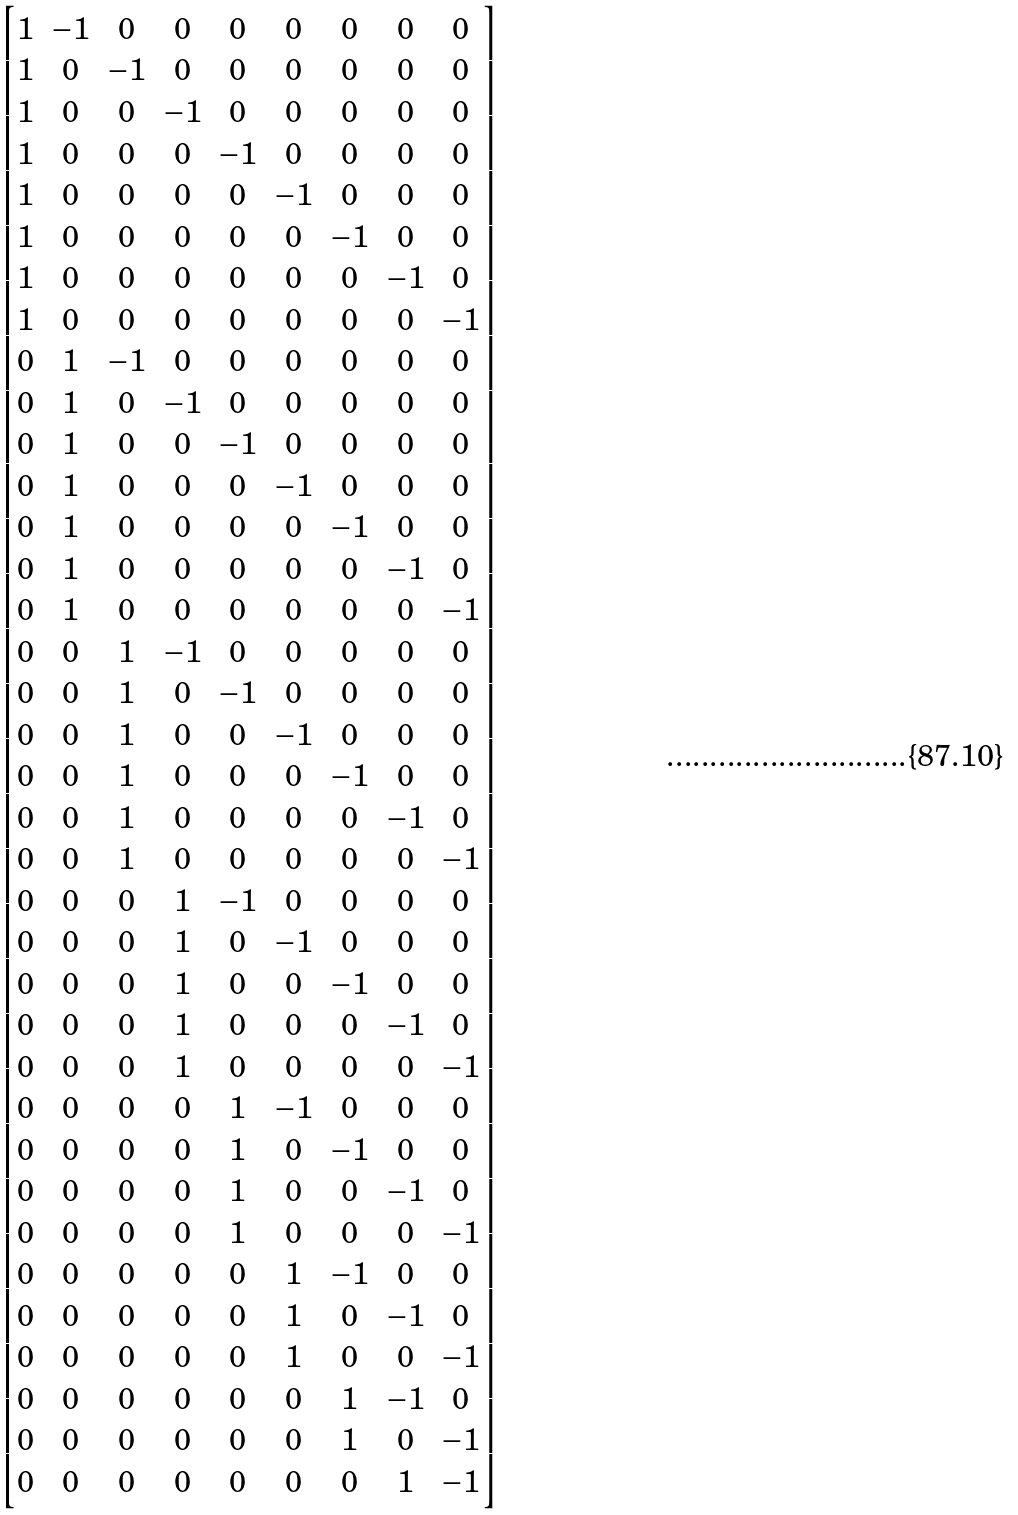Convert formula to latex. <formula><loc_0><loc_0><loc_500><loc_500>\begin{bmatrix} 1 & - 1 & 0 & 0 & 0 & 0 & 0 & 0 & 0 \\ 1 & 0 & - 1 & 0 & 0 & 0 & 0 & 0 & 0 \\ 1 & 0 & 0 & - 1 & 0 & 0 & 0 & 0 & 0 \\ 1 & 0 & 0 & 0 & - 1 & 0 & 0 & 0 & 0 \\ 1 & 0 & 0 & 0 & 0 & - 1 & 0 & 0 & 0 \\ 1 & 0 & 0 & 0 & 0 & 0 & - 1 & 0 & 0 \\ 1 & 0 & 0 & 0 & 0 & 0 & 0 & - 1 & 0 \\ 1 & 0 & 0 & 0 & 0 & 0 & 0 & 0 & - 1 \\ 0 & 1 & - 1 & 0 & 0 & 0 & 0 & 0 & 0 \\ 0 & 1 & 0 & - 1 & 0 & 0 & 0 & 0 & 0 \\ 0 & 1 & 0 & 0 & - 1 & 0 & 0 & 0 & 0 \\ 0 & 1 & 0 & 0 & 0 & - 1 & 0 & 0 & 0 \\ 0 & 1 & 0 & 0 & 0 & 0 & - 1 & 0 & 0 \\ 0 & 1 & 0 & 0 & 0 & 0 & 0 & - 1 & 0 \\ 0 & 1 & 0 & 0 & 0 & 0 & 0 & 0 & - 1 \\ 0 & 0 & 1 & - 1 & 0 & 0 & 0 & 0 & 0 \\ 0 & 0 & 1 & 0 & - 1 & 0 & 0 & 0 & 0 \\ 0 & 0 & 1 & 0 & 0 & - 1 & 0 & 0 & 0 \\ 0 & 0 & 1 & 0 & 0 & 0 & - 1 & 0 & 0 \\ 0 & 0 & 1 & 0 & 0 & 0 & 0 & - 1 & 0 \\ 0 & 0 & 1 & 0 & 0 & 0 & 0 & 0 & - 1 \\ 0 & 0 & 0 & 1 & - 1 & 0 & 0 & 0 & 0 \\ 0 & 0 & 0 & 1 & 0 & - 1 & 0 & 0 & 0 \\ 0 & 0 & 0 & 1 & 0 & 0 & - 1 & 0 & 0 \\ 0 & 0 & 0 & 1 & 0 & 0 & 0 & - 1 & 0 \\ 0 & 0 & 0 & 1 & 0 & 0 & 0 & 0 & - 1 \\ 0 & 0 & 0 & 0 & 1 & - 1 & 0 & 0 & 0 \\ 0 & 0 & 0 & 0 & 1 & 0 & - 1 & 0 & 0 \\ 0 & 0 & 0 & 0 & 1 & 0 & 0 & - 1 & 0 \\ 0 & 0 & 0 & 0 & 1 & 0 & 0 & 0 & - 1 \\ 0 & 0 & 0 & 0 & 0 & 1 & - 1 & 0 & 0 \\ 0 & 0 & 0 & 0 & 0 & 1 & 0 & - 1 & 0 \\ 0 & 0 & 0 & 0 & 0 & 1 & 0 & 0 & - 1 \\ 0 & 0 & 0 & 0 & 0 & 0 & 1 & - 1 & 0 \\ 0 & 0 & 0 & 0 & 0 & 0 & 1 & 0 & - 1 \\ 0 & 0 & 0 & 0 & 0 & 0 & 0 & 1 & - 1 \end{bmatrix}</formula> 